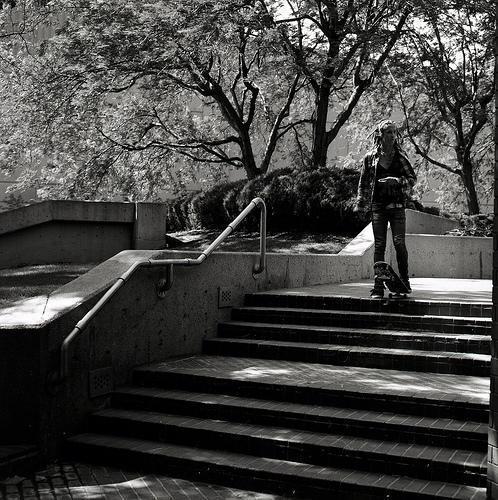How many people are in the photo?
Give a very brief answer. 1. 